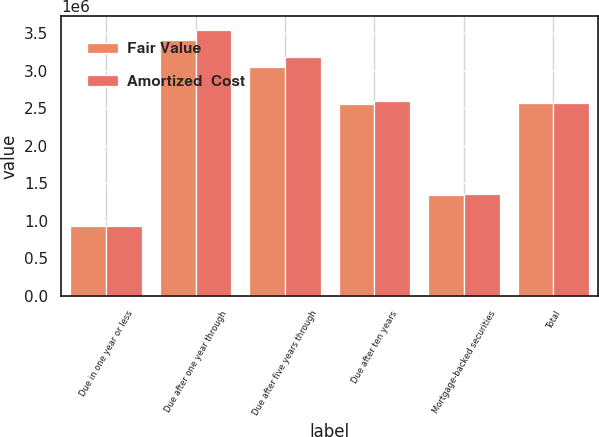Convert chart to OTSL. <chart><loc_0><loc_0><loc_500><loc_500><stacked_bar_chart><ecel><fcel>Due in one year or less<fcel>Due after one year through<fcel>Due after five years through<fcel>Due after ten years<fcel>Mortgage-backed securities<fcel>Total<nl><fcel>Fair Value<fcel>926865<fcel>3.41103e+06<fcel>3.04676e+06<fcel>2.55444e+06<fcel>1.35254e+06<fcel>2.57547e+06<nl><fcel>Amortized  Cost<fcel>935322<fcel>3.54804e+06<fcel>3.19139e+06<fcel>2.5965e+06<fcel>1.36049e+06<fcel>2.57547e+06<nl></chart> 